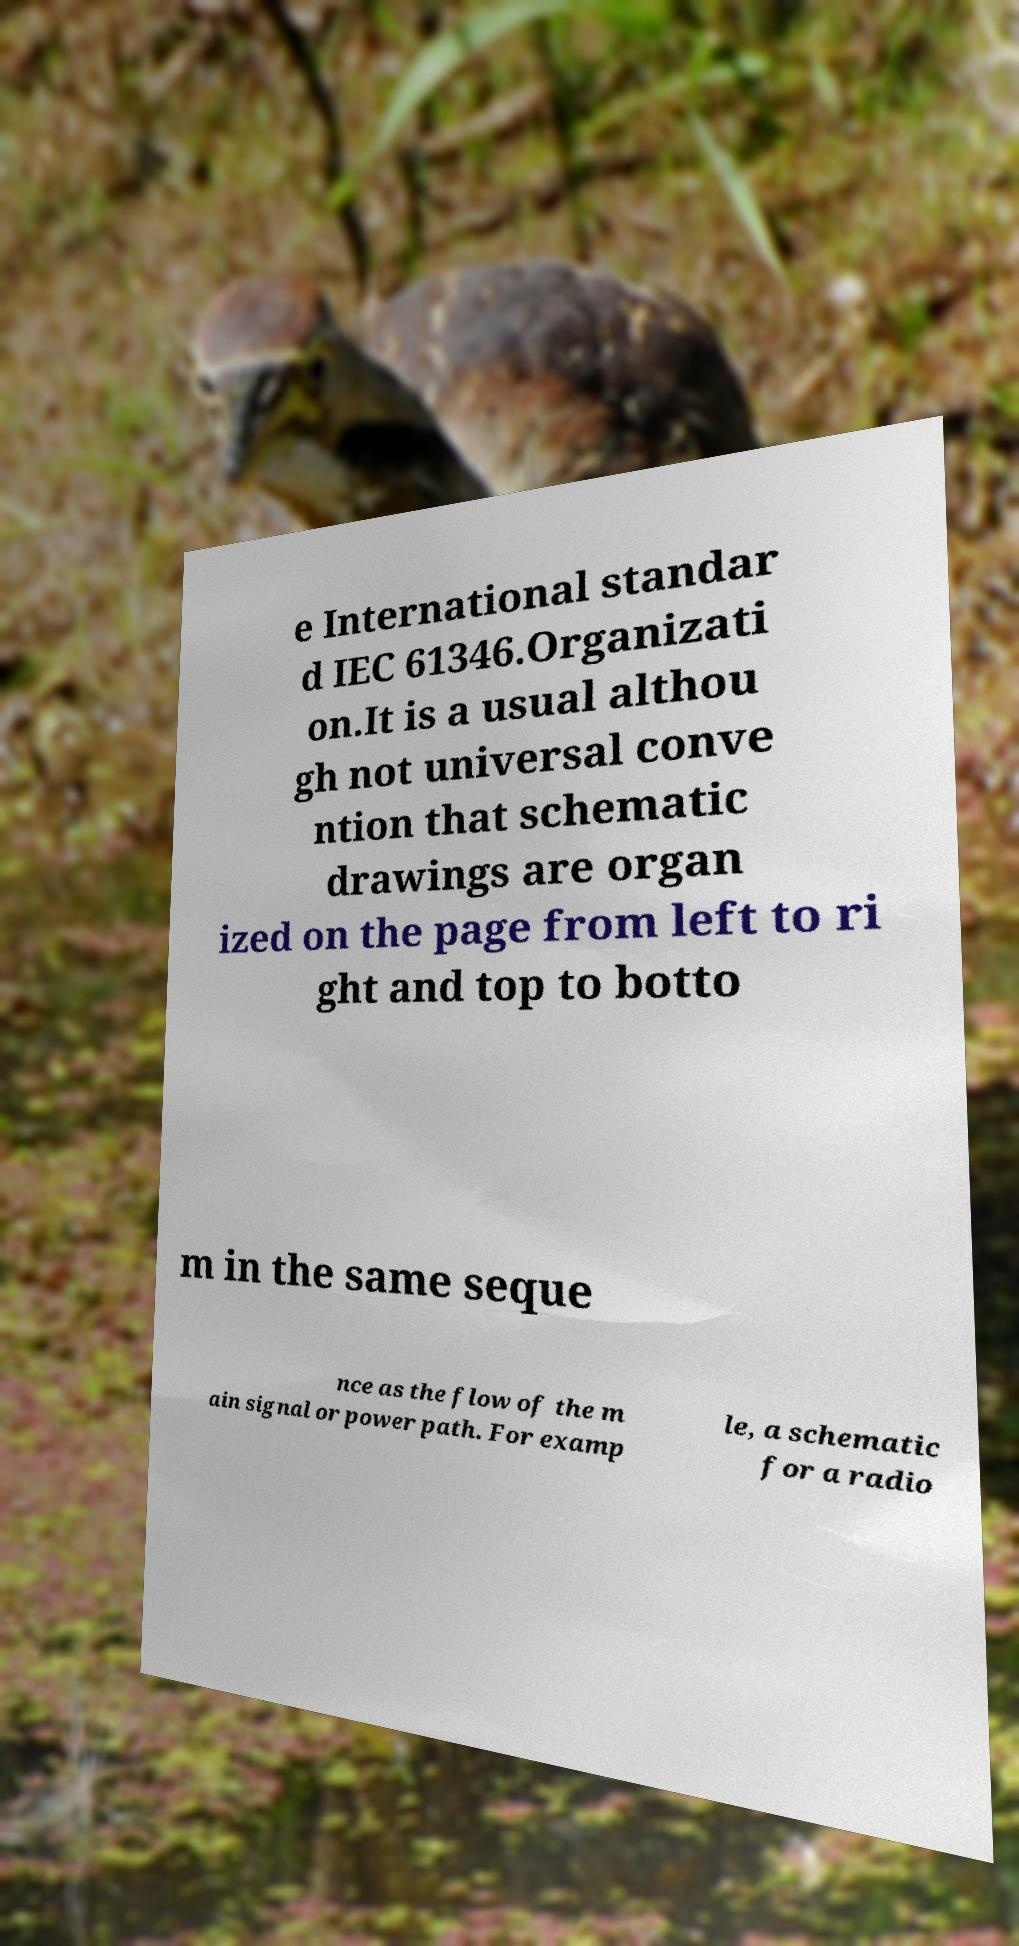Can you accurately transcribe the text from the provided image for me? e International standar d IEC 61346.Organizati on.It is a usual althou gh not universal conve ntion that schematic drawings are organ ized on the page from left to ri ght and top to botto m in the same seque nce as the flow of the m ain signal or power path. For examp le, a schematic for a radio 